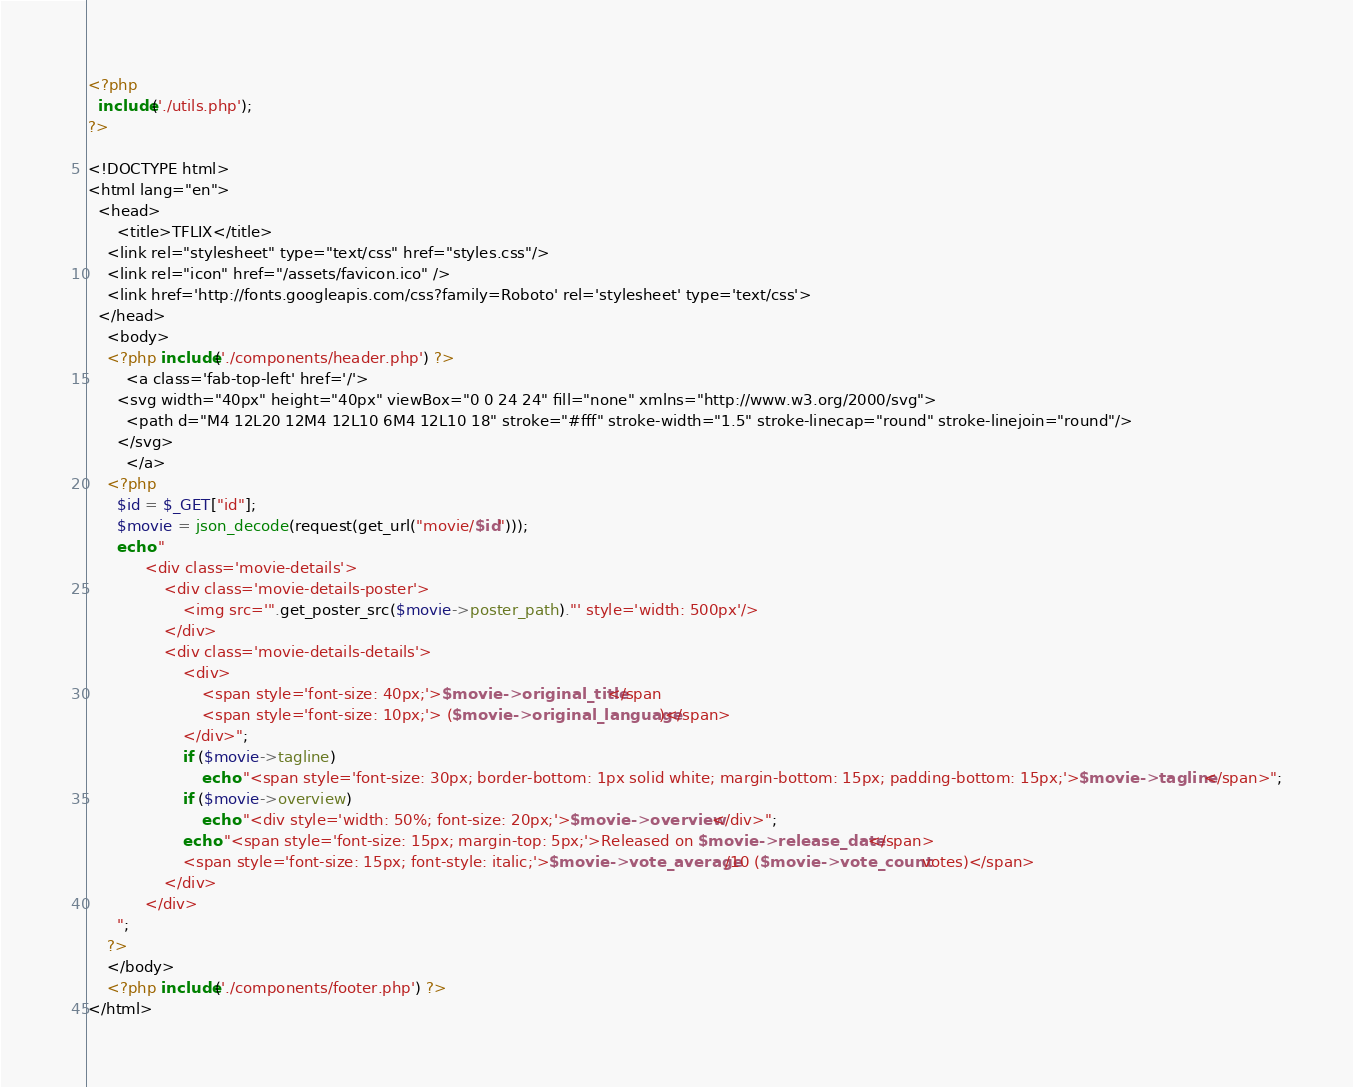<code> <loc_0><loc_0><loc_500><loc_500><_PHP_><?php
  include('./utils.php');
?>

<!DOCTYPE html>
<html lang="en">
  <head>
	  <title>TFLIX</title>
    <link rel="stylesheet" type="text/css" href="styles.css"/>
    <link rel="icon" href="/assets/favicon.ico" />
    <link href='http://fonts.googleapis.com/css?family=Roboto' rel='stylesheet' type='text/css'>
  </head>
	<body>
    <?php include('./components/header.php') ?>
		<a class='fab-top-left' href='/'>
      <svg width="40px" height="40px" viewBox="0 0 24 24" fill="none" xmlns="http://www.w3.org/2000/svg">
        <path d="M4 12L20 12M4 12L10 6M4 12L10 18" stroke="#fff" stroke-width="1.5" stroke-linecap="round" stroke-linejoin="round"/>
      </svg>
		</a>
    <?php
      $id = $_GET["id"];
      $movie = json_decode(request(get_url("movie/$id")));
      echo "
			<div class='movie-details'>
				<div class='movie-details-poster'>
					<img src='".get_poster_src($movie->poster_path)."' style='width: 500px'/>
				</div>
				<div class='movie-details-details'>
					<div>
						<span style='font-size: 40px;'>$movie->original_title</span
						<span style='font-size: 10px;'> ($movie->original_language)</span>
					</div>";
					if ($movie->tagline)
						echo "<span style='font-size: 30px; border-bottom: 1px solid white; margin-bottom: 15px; padding-bottom: 15px;'>$movie->tagline</span>";
					if ($movie->overview)
						echo "<div style='width: 50%; font-size: 20px;'>$movie->overview</div>";
					echo "<span style='font-size: 15px; margin-top: 5px;'>Released on $movie->release_date</span>
					<span style='font-size: 15px; font-style: italic;'>$movie->vote_average/10 ($movie->vote_count votes)</span>
				</div>
			</div>
      ";
    ?>
	</body>
    <?php include('./components/footer.php') ?>
</html></code> 